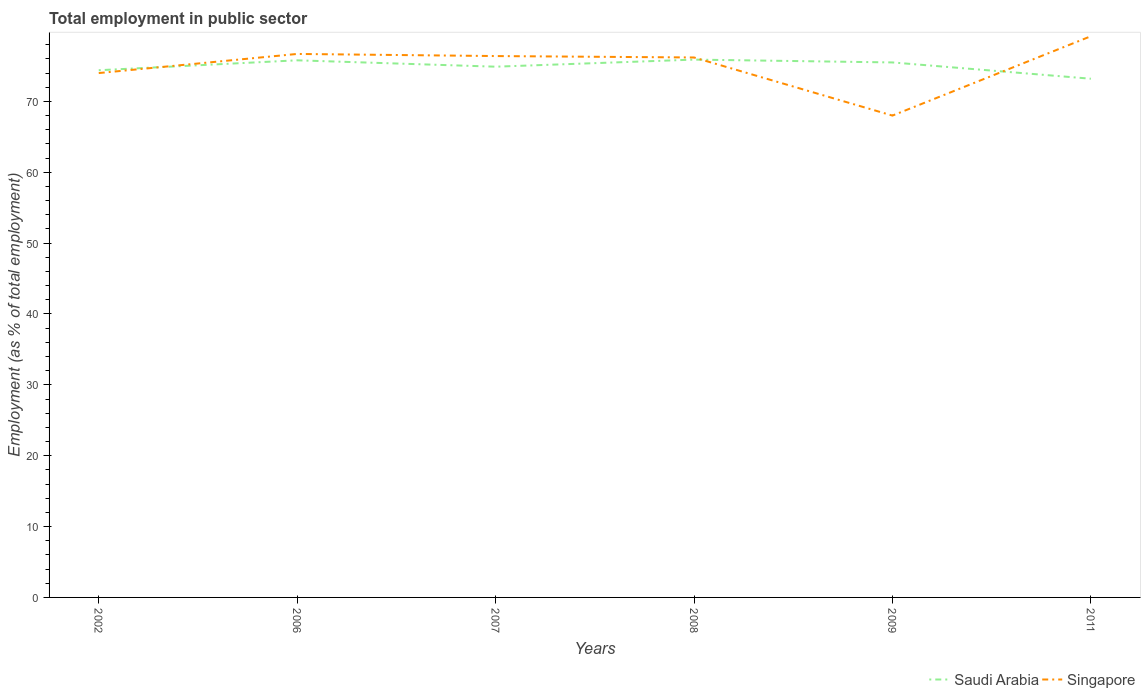Is the number of lines equal to the number of legend labels?
Keep it short and to the point. Yes. Across all years, what is the maximum employment in public sector in Singapore?
Offer a terse response. 68. What is the total employment in public sector in Singapore in the graph?
Provide a succinct answer. 6. What is the difference between the highest and the second highest employment in public sector in Saudi Arabia?
Offer a very short reply. 2.7. What is the difference between two consecutive major ticks on the Y-axis?
Your answer should be very brief. 10. Does the graph contain grids?
Keep it short and to the point. No. How are the legend labels stacked?
Provide a short and direct response. Horizontal. What is the title of the graph?
Provide a short and direct response. Total employment in public sector. What is the label or title of the Y-axis?
Ensure brevity in your answer.  Employment (as % of total employment). What is the Employment (as % of total employment) of Saudi Arabia in 2002?
Provide a short and direct response. 74.4. What is the Employment (as % of total employment) in Saudi Arabia in 2006?
Your response must be concise. 75.8. What is the Employment (as % of total employment) in Singapore in 2006?
Offer a terse response. 76.7. What is the Employment (as % of total employment) of Saudi Arabia in 2007?
Your response must be concise. 74.9. What is the Employment (as % of total employment) in Singapore in 2007?
Provide a short and direct response. 76.4. What is the Employment (as % of total employment) in Saudi Arabia in 2008?
Your answer should be compact. 75.9. What is the Employment (as % of total employment) of Singapore in 2008?
Your answer should be very brief. 76.2. What is the Employment (as % of total employment) in Saudi Arabia in 2009?
Provide a succinct answer. 75.5. What is the Employment (as % of total employment) of Saudi Arabia in 2011?
Ensure brevity in your answer.  73.2. What is the Employment (as % of total employment) of Singapore in 2011?
Offer a very short reply. 79.2. Across all years, what is the maximum Employment (as % of total employment) in Saudi Arabia?
Give a very brief answer. 75.9. Across all years, what is the maximum Employment (as % of total employment) in Singapore?
Offer a terse response. 79.2. Across all years, what is the minimum Employment (as % of total employment) in Saudi Arabia?
Make the answer very short. 73.2. Across all years, what is the minimum Employment (as % of total employment) of Singapore?
Your answer should be compact. 68. What is the total Employment (as % of total employment) in Saudi Arabia in the graph?
Make the answer very short. 449.7. What is the total Employment (as % of total employment) of Singapore in the graph?
Your answer should be compact. 450.5. What is the difference between the Employment (as % of total employment) of Saudi Arabia in 2002 and that in 2006?
Offer a terse response. -1.4. What is the difference between the Employment (as % of total employment) in Singapore in 2002 and that in 2006?
Offer a terse response. -2.7. What is the difference between the Employment (as % of total employment) in Saudi Arabia in 2002 and that in 2007?
Provide a short and direct response. -0.5. What is the difference between the Employment (as % of total employment) of Singapore in 2002 and that in 2007?
Provide a succinct answer. -2.4. What is the difference between the Employment (as % of total employment) of Singapore in 2002 and that in 2011?
Your answer should be very brief. -5.2. What is the difference between the Employment (as % of total employment) in Saudi Arabia in 2006 and that in 2007?
Your answer should be very brief. 0.9. What is the difference between the Employment (as % of total employment) in Saudi Arabia in 2006 and that in 2008?
Give a very brief answer. -0.1. What is the difference between the Employment (as % of total employment) in Singapore in 2006 and that in 2008?
Make the answer very short. 0.5. What is the difference between the Employment (as % of total employment) of Saudi Arabia in 2006 and that in 2011?
Offer a terse response. 2.6. What is the difference between the Employment (as % of total employment) in Saudi Arabia in 2007 and that in 2008?
Keep it short and to the point. -1. What is the difference between the Employment (as % of total employment) in Saudi Arabia in 2007 and that in 2009?
Your response must be concise. -0.6. What is the difference between the Employment (as % of total employment) of Singapore in 2009 and that in 2011?
Provide a succinct answer. -11.2. What is the difference between the Employment (as % of total employment) of Saudi Arabia in 2002 and the Employment (as % of total employment) of Singapore in 2009?
Give a very brief answer. 6.4. What is the difference between the Employment (as % of total employment) of Saudi Arabia in 2006 and the Employment (as % of total employment) of Singapore in 2008?
Your answer should be compact. -0.4. What is the difference between the Employment (as % of total employment) of Saudi Arabia in 2006 and the Employment (as % of total employment) of Singapore in 2009?
Make the answer very short. 7.8. What is the difference between the Employment (as % of total employment) of Saudi Arabia in 2007 and the Employment (as % of total employment) of Singapore in 2008?
Give a very brief answer. -1.3. What is the difference between the Employment (as % of total employment) of Saudi Arabia in 2007 and the Employment (as % of total employment) of Singapore in 2009?
Provide a short and direct response. 6.9. What is the difference between the Employment (as % of total employment) of Saudi Arabia in 2008 and the Employment (as % of total employment) of Singapore in 2009?
Your response must be concise. 7.9. What is the difference between the Employment (as % of total employment) of Saudi Arabia in 2008 and the Employment (as % of total employment) of Singapore in 2011?
Your answer should be compact. -3.3. What is the average Employment (as % of total employment) in Saudi Arabia per year?
Your response must be concise. 74.95. What is the average Employment (as % of total employment) in Singapore per year?
Your answer should be compact. 75.08. In the year 2006, what is the difference between the Employment (as % of total employment) in Saudi Arabia and Employment (as % of total employment) in Singapore?
Make the answer very short. -0.9. In the year 2008, what is the difference between the Employment (as % of total employment) of Saudi Arabia and Employment (as % of total employment) of Singapore?
Your response must be concise. -0.3. In the year 2009, what is the difference between the Employment (as % of total employment) of Saudi Arabia and Employment (as % of total employment) of Singapore?
Keep it short and to the point. 7.5. In the year 2011, what is the difference between the Employment (as % of total employment) in Saudi Arabia and Employment (as % of total employment) in Singapore?
Provide a short and direct response. -6. What is the ratio of the Employment (as % of total employment) in Saudi Arabia in 2002 to that in 2006?
Give a very brief answer. 0.98. What is the ratio of the Employment (as % of total employment) in Singapore in 2002 to that in 2006?
Your answer should be very brief. 0.96. What is the ratio of the Employment (as % of total employment) in Saudi Arabia in 2002 to that in 2007?
Offer a very short reply. 0.99. What is the ratio of the Employment (as % of total employment) of Singapore in 2002 to that in 2007?
Offer a terse response. 0.97. What is the ratio of the Employment (as % of total employment) in Saudi Arabia in 2002 to that in 2008?
Keep it short and to the point. 0.98. What is the ratio of the Employment (as % of total employment) in Singapore in 2002 to that in 2008?
Your response must be concise. 0.97. What is the ratio of the Employment (as % of total employment) of Saudi Arabia in 2002 to that in 2009?
Offer a very short reply. 0.99. What is the ratio of the Employment (as % of total employment) in Singapore in 2002 to that in 2009?
Offer a terse response. 1.09. What is the ratio of the Employment (as % of total employment) in Saudi Arabia in 2002 to that in 2011?
Keep it short and to the point. 1.02. What is the ratio of the Employment (as % of total employment) of Singapore in 2002 to that in 2011?
Make the answer very short. 0.93. What is the ratio of the Employment (as % of total employment) in Singapore in 2006 to that in 2008?
Give a very brief answer. 1.01. What is the ratio of the Employment (as % of total employment) in Singapore in 2006 to that in 2009?
Keep it short and to the point. 1.13. What is the ratio of the Employment (as % of total employment) in Saudi Arabia in 2006 to that in 2011?
Provide a short and direct response. 1.04. What is the ratio of the Employment (as % of total employment) of Singapore in 2006 to that in 2011?
Provide a succinct answer. 0.97. What is the ratio of the Employment (as % of total employment) in Saudi Arabia in 2007 to that in 2008?
Offer a very short reply. 0.99. What is the ratio of the Employment (as % of total employment) of Singapore in 2007 to that in 2008?
Make the answer very short. 1. What is the ratio of the Employment (as % of total employment) of Saudi Arabia in 2007 to that in 2009?
Make the answer very short. 0.99. What is the ratio of the Employment (as % of total employment) of Singapore in 2007 to that in 2009?
Provide a short and direct response. 1.12. What is the ratio of the Employment (as % of total employment) in Saudi Arabia in 2007 to that in 2011?
Provide a succinct answer. 1.02. What is the ratio of the Employment (as % of total employment) in Singapore in 2007 to that in 2011?
Provide a short and direct response. 0.96. What is the ratio of the Employment (as % of total employment) of Saudi Arabia in 2008 to that in 2009?
Ensure brevity in your answer.  1.01. What is the ratio of the Employment (as % of total employment) of Singapore in 2008 to that in 2009?
Your response must be concise. 1.12. What is the ratio of the Employment (as % of total employment) of Saudi Arabia in 2008 to that in 2011?
Offer a very short reply. 1.04. What is the ratio of the Employment (as % of total employment) in Singapore in 2008 to that in 2011?
Provide a short and direct response. 0.96. What is the ratio of the Employment (as % of total employment) in Saudi Arabia in 2009 to that in 2011?
Keep it short and to the point. 1.03. What is the ratio of the Employment (as % of total employment) of Singapore in 2009 to that in 2011?
Your answer should be compact. 0.86. What is the difference between the highest and the second highest Employment (as % of total employment) of Saudi Arabia?
Your answer should be compact. 0.1. What is the difference between the highest and the second highest Employment (as % of total employment) in Singapore?
Your response must be concise. 2.5. What is the difference between the highest and the lowest Employment (as % of total employment) in Saudi Arabia?
Your response must be concise. 2.7. 